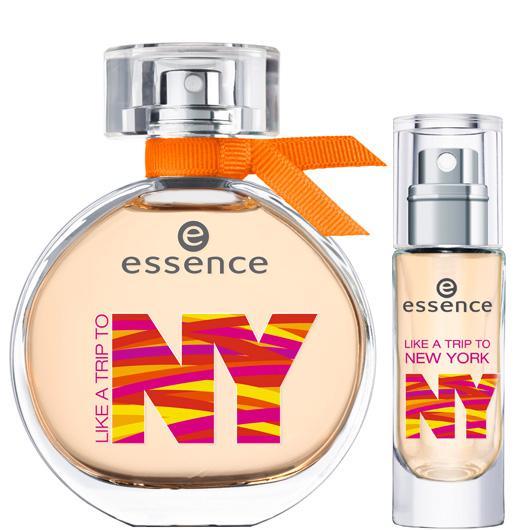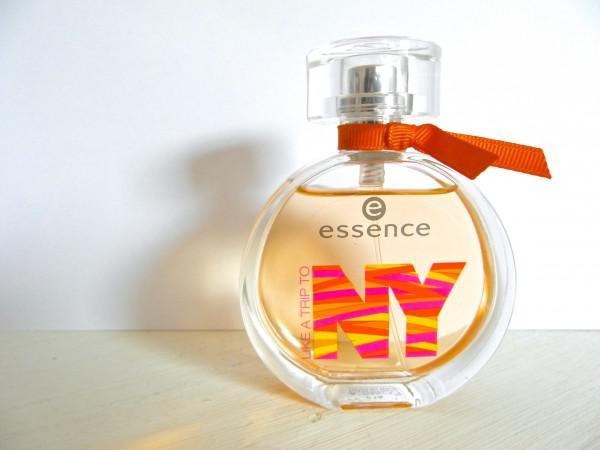The first image is the image on the left, the second image is the image on the right. Examine the images to the left and right. Is the description "there is at least one perfume bottle with a clear cap" accurate? Answer yes or no. Yes. The first image is the image on the left, the second image is the image on the right. Examine the images to the left and right. Is the description "The right image contains a slender perfume container that is predominately red." accurate? Answer yes or no. No. 